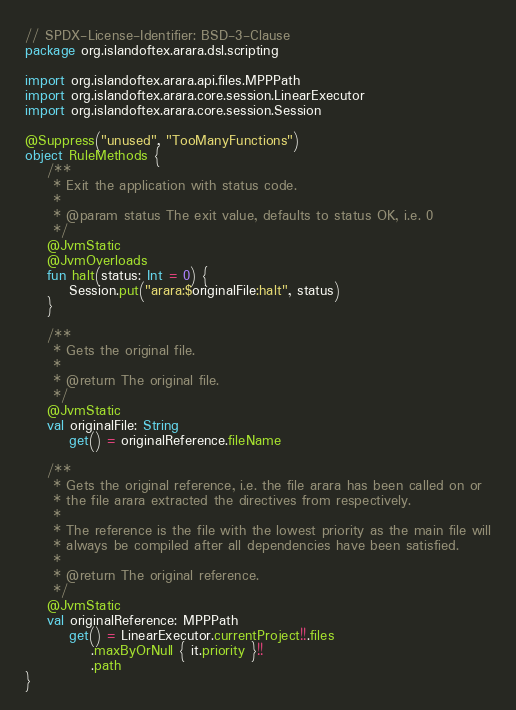Convert code to text. <code><loc_0><loc_0><loc_500><loc_500><_Kotlin_>// SPDX-License-Identifier: BSD-3-Clause
package org.islandoftex.arara.dsl.scripting

import org.islandoftex.arara.api.files.MPPPath
import org.islandoftex.arara.core.session.LinearExecutor
import org.islandoftex.arara.core.session.Session

@Suppress("unused", "TooManyFunctions")
object RuleMethods {
    /**
     * Exit the application with status code.
     *
     * @param status The exit value, defaults to status OK, i.e. 0
     */
    @JvmStatic
    @JvmOverloads
    fun halt(status: Int = 0) {
        Session.put("arara:$originalFile:halt", status)
    }

    /**
     * Gets the original file.
     *
     * @return The original file.
     */
    @JvmStatic
    val originalFile: String
        get() = originalReference.fileName

    /**
     * Gets the original reference, i.e. the file arara has been called on or
     * the file arara extracted the directives from respectively.
     *
     * The reference is the file with the lowest priority as the main file will
     * always be compiled after all dependencies have been satisfied.
     *
     * @return The original reference.
     */
    @JvmStatic
    val originalReference: MPPPath
        get() = LinearExecutor.currentProject!!.files
            .maxByOrNull { it.priority }!!
            .path
}
</code> 